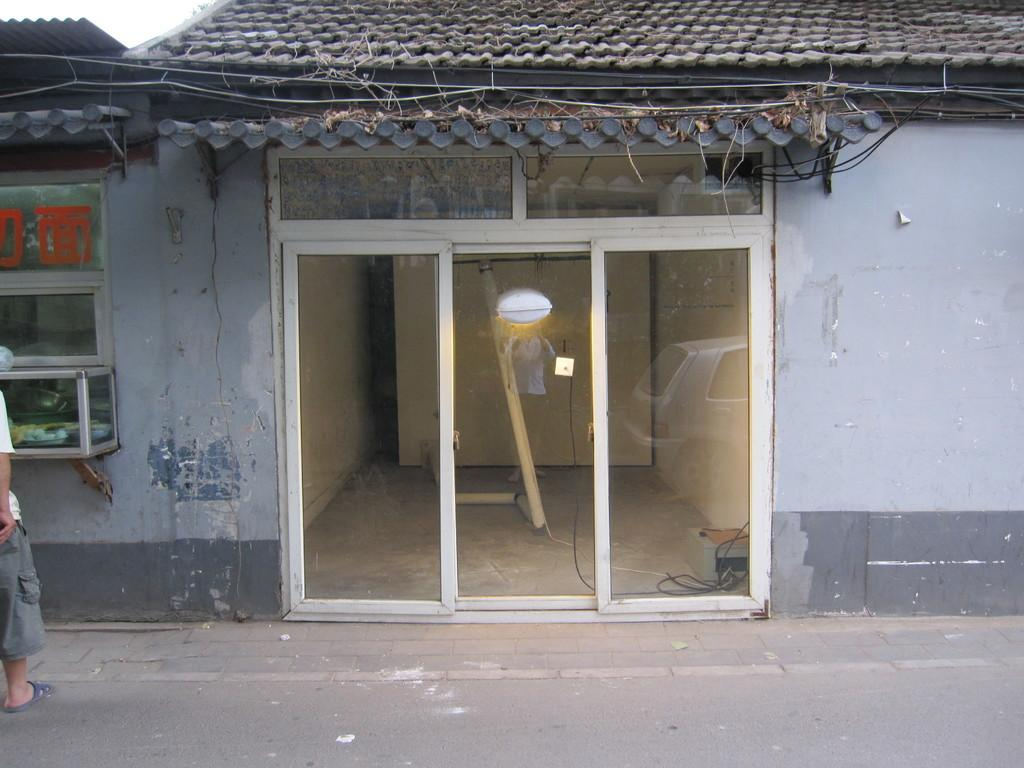What type of structure is visible in the image? There is a building in the image. What feature can be seen on the building? There is a glass window in the image. Where is the person located in relation to the building? A person is standing on the road in front of the building. What type of eggs can be seen rolling down the road in the image? There are no eggs present in the image, let alone rolling down the road. 